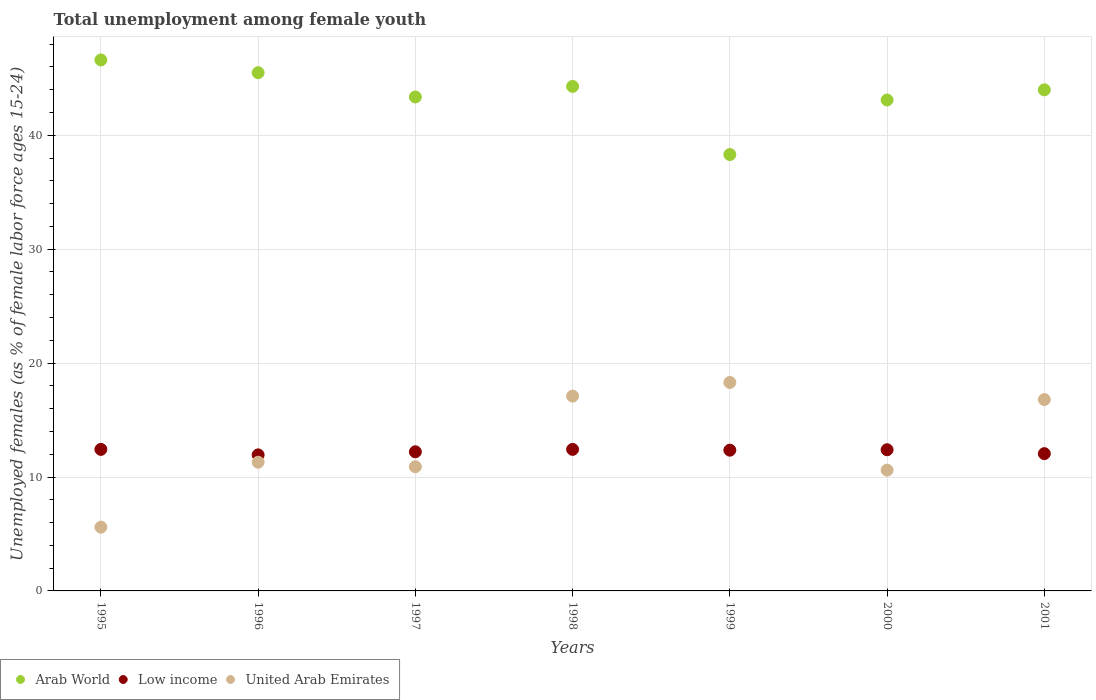What is the percentage of unemployed females in in United Arab Emirates in 1995?
Offer a terse response. 5.6. Across all years, what is the maximum percentage of unemployed females in in Low income?
Offer a very short reply. 12.43. Across all years, what is the minimum percentage of unemployed females in in United Arab Emirates?
Make the answer very short. 5.6. What is the total percentage of unemployed females in in United Arab Emirates in the graph?
Make the answer very short. 90.6. What is the difference between the percentage of unemployed females in in Arab World in 1997 and that in 2001?
Give a very brief answer. -0.63. What is the difference between the percentage of unemployed females in in Low income in 1998 and the percentage of unemployed females in in United Arab Emirates in 1995?
Your answer should be compact. 6.83. What is the average percentage of unemployed females in in Low income per year?
Offer a very short reply. 12.26. In the year 2001, what is the difference between the percentage of unemployed females in in Low income and percentage of unemployed females in in Arab World?
Your answer should be very brief. -31.94. What is the ratio of the percentage of unemployed females in in Arab World in 1997 to that in 2000?
Your answer should be compact. 1.01. What is the difference between the highest and the second highest percentage of unemployed females in in Arab World?
Provide a succinct answer. 1.12. What is the difference between the highest and the lowest percentage of unemployed females in in Low income?
Ensure brevity in your answer.  0.48. Is the sum of the percentage of unemployed females in in United Arab Emirates in 1998 and 2001 greater than the maximum percentage of unemployed females in in Low income across all years?
Provide a succinct answer. Yes. Does the percentage of unemployed females in in United Arab Emirates monotonically increase over the years?
Your answer should be compact. No. Is the percentage of unemployed females in in Low income strictly less than the percentage of unemployed females in in Arab World over the years?
Ensure brevity in your answer.  Yes. How many years are there in the graph?
Make the answer very short. 7. Where does the legend appear in the graph?
Your response must be concise. Bottom left. How are the legend labels stacked?
Ensure brevity in your answer.  Horizontal. What is the title of the graph?
Give a very brief answer. Total unemployment among female youth. What is the label or title of the X-axis?
Your answer should be compact. Years. What is the label or title of the Y-axis?
Your response must be concise. Unemployed females (as % of female labor force ages 15-24). What is the Unemployed females (as % of female labor force ages 15-24) of Arab World in 1995?
Your response must be concise. 46.61. What is the Unemployed females (as % of female labor force ages 15-24) in Low income in 1995?
Keep it short and to the point. 12.42. What is the Unemployed females (as % of female labor force ages 15-24) of United Arab Emirates in 1995?
Make the answer very short. 5.6. What is the Unemployed females (as % of female labor force ages 15-24) of Arab World in 1996?
Provide a succinct answer. 45.49. What is the Unemployed females (as % of female labor force ages 15-24) in Low income in 1996?
Give a very brief answer. 11.94. What is the Unemployed females (as % of female labor force ages 15-24) of United Arab Emirates in 1996?
Your answer should be very brief. 11.3. What is the Unemployed females (as % of female labor force ages 15-24) of Arab World in 1997?
Provide a succinct answer. 43.36. What is the Unemployed females (as % of female labor force ages 15-24) in Low income in 1997?
Provide a succinct answer. 12.21. What is the Unemployed females (as % of female labor force ages 15-24) of United Arab Emirates in 1997?
Make the answer very short. 10.9. What is the Unemployed females (as % of female labor force ages 15-24) in Arab World in 1998?
Make the answer very short. 44.29. What is the Unemployed females (as % of female labor force ages 15-24) in Low income in 1998?
Ensure brevity in your answer.  12.43. What is the Unemployed females (as % of female labor force ages 15-24) in United Arab Emirates in 1998?
Your answer should be compact. 17.1. What is the Unemployed females (as % of female labor force ages 15-24) of Arab World in 1999?
Your answer should be very brief. 38.31. What is the Unemployed females (as % of female labor force ages 15-24) in Low income in 1999?
Your answer should be very brief. 12.36. What is the Unemployed females (as % of female labor force ages 15-24) of United Arab Emirates in 1999?
Offer a very short reply. 18.3. What is the Unemployed females (as % of female labor force ages 15-24) of Arab World in 2000?
Make the answer very short. 43.1. What is the Unemployed females (as % of female labor force ages 15-24) in Low income in 2000?
Offer a terse response. 12.39. What is the Unemployed females (as % of female labor force ages 15-24) in United Arab Emirates in 2000?
Offer a terse response. 10.6. What is the Unemployed females (as % of female labor force ages 15-24) in Arab World in 2001?
Your answer should be compact. 43.99. What is the Unemployed females (as % of female labor force ages 15-24) of Low income in 2001?
Offer a very short reply. 12.05. What is the Unemployed females (as % of female labor force ages 15-24) of United Arab Emirates in 2001?
Offer a terse response. 16.8. Across all years, what is the maximum Unemployed females (as % of female labor force ages 15-24) in Arab World?
Ensure brevity in your answer.  46.61. Across all years, what is the maximum Unemployed females (as % of female labor force ages 15-24) of Low income?
Keep it short and to the point. 12.43. Across all years, what is the maximum Unemployed females (as % of female labor force ages 15-24) of United Arab Emirates?
Provide a short and direct response. 18.3. Across all years, what is the minimum Unemployed females (as % of female labor force ages 15-24) in Arab World?
Your answer should be very brief. 38.31. Across all years, what is the minimum Unemployed females (as % of female labor force ages 15-24) in Low income?
Your answer should be compact. 11.94. Across all years, what is the minimum Unemployed females (as % of female labor force ages 15-24) of United Arab Emirates?
Keep it short and to the point. 5.6. What is the total Unemployed females (as % of female labor force ages 15-24) in Arab World in the graph?
Give a very brief answer. 305.14. What is the total Unemployed females (as % of female labor force ages 15-24) in Low income in the graph?
Provide a succinct answer. 85.81. What is the total Unemployed females (as % of female labor force ages 15-24) in United Arab Emirates in the graph?
Your answer should be very brief. 90.6. What is the difference between the Unemployed females (as % of female labor force ages 15-24) in Arab World in 1995 and that in 1996?
Keep it short and to the point. 1.12. What is the difference between the Unemployed females (as % of female labor force ages 15-24) of Low income in 1995 and that in 1996?
Your answer should be very brief. 0.48. What is the difference between the Unemployed females (as % of female labor force ages 15-24) of United Arab Emirates in 1995 and that in 1996?
Keep it short and to the point. -5.7. What is the difference between the Unemployed females (as % of female labor force ages 15-24) in Arab World in 1995 and that in 1997?
Your answer should be compact. 3.25. What is the difference between the Unemployed females (as % of female labor force ages 15-24) of Low income in 1995 and that in 1997?
Provide a short and direct response. 0.21. What is the difference between the Unemployed females (as % of female labor force ages 15-24) of United Arab Emirates in 1995 and that in 1997?
Give a very brief answer. -5.3. What is the difference between the Unemployed females (as % of female labor force ages 15-24) in Arab World in 1995 and that in 1998?
Your answer should be very brief. 2.32. What is the difference between the Unemployed females (as % of female labor force ages 15-24) of Low income in 1995 and that in 1998?
Provide a short and direct response. -0. What is the difference between the Unemployed females (as % of female labor force ages 15-24) of Arab World in 1995 and that in 1999?
Offer a terse response. 8.3. What is the difference between the Unemployed females (as % of female labor force ages 15-24) in Low income in 1995 and that in 1999?
Offer a very short reply. 0.07. What is the difference between the Unemployed females (as % of female labor force ages 15-24) of Arab World in 1995 and that in 2000?
Offer a terse response. 3.52. What is the difference between the Unemployed females (as % of female labor force ages 15-24) of Low income in 1995 and that in 2000?
Your response must be concise. 0.03. What is the difference between the Unemployed females (as % of female labor force ages 15-24) in United Arab Emirates in 1995 and that in 2000?
Provide a short and direct response. -5. What is the difference between the Unemployed females (as % of female labor force ages 15-24) of Arab World in 1995 and that in 2001?
Give a very brief answer. 2.62. What is the difference between the Unemployed females (as % of female labor force ages 15-24) in Low income in 1995 and that in 2001?
Your response must be concise. 0.37. What is the difference between the Unemployed females (as % of female labor force ages 15-24) of United Arab Emirates in 1995 and that in 2001?
Provide a succinct answer. -11.2. What is the difference between the Unemployed females (as % of female labor force ages 15-24) of Arab World in 1996 and that in 1997?
Make the answer very short. 2.13. What is the difference between the Unemployed females (as % of female labor force ages 15-24) in Low income in 1996 and that in 1997?
Give a very brief answer. -0.27. What is the difference between the Unemployed females (as % of female labor force ages 15-24) in United Arab Emirates in 1996 and that in 1997?
Provide a short and direct response. 0.4. What is the difference between the Unemployed females (as % of female labor force ages 15-24) of Arab World in 1996 and that in 1998?
Your answer should be very brief. 1.21. What is the difference between the Unemployed females (as % of female labor force ages 15-24) of Low income in 1996 and that in 1998?
Your response must be concise. -0.48. What is the difference between the Unemployed females (as % of female labor force ages 15-24) of United Arab Emirates in 1996 and that in 1998?
Give a very brief answer. -5.8. What is the difference between the Unemployed females (as % of female labor force ages 15-24) in Arab World in 1996 and that in 1999?
Ensure brevity in your answer.  7.18. What is the difference between the Unemployed females (as % of female labor force ages 15-24) of Low income in 1996 and that in 1999?
Your response must be concise. -0.41. What is the difference between the Unemployed females (as % of female labor force ages 15-24) of Arab World in 1996 and that in 2000?
Make the answer very short. 2.4. What is the difference between the Unemployed females (as % of female labor force ages 15-24) of Low income in 1996 and that in 2000?
Provide a succinct answer. -0.45. What is the difference between the Unemployed females (as % of female labor force ages 15-24) of United Arab Emirates in 1996 and that in 2000?
Provide a short and direct response. 0.7. What is the difference between the Unemployed females (as % of female labor force ages 15-24) in Arab World in 1996 and that in 2001?
Offer a terse response. 1.51. What is the difference between the Unemployed females (as % of female labor force ages 15-24) in Low income in 1996 and that in 2001?
Provide a succinct answer. -0.11. What is the difference between the Unemployed females (as % of female labor force ages 15-24) of United Arab Emirates in 1996 and that in 2001?
Keep it short and to the point. -5.5. What is the difference between the Unemployed females (as % of female labor force ages 15-24) of Arab World in 1997 and that in 1998?
Keep it short and to the point. -0.93. What is the difference between the Unemployed females (as % of female labor force ages 15-24) of Low income in 1997 and that in 1998?
Ensure brevity in your answer.  -0.21. What is the difference between the Unemployed females (as % of female labor force ages 15-24) of Arab World in 1997 and that in 1999?
Offer a very short reply. 5.05. What is the difference between the Unemployed females (as % of female labor force ages 15-24) of Low income in 1997 and that in 1999?
Give a very brief answer. -0.14. What is the difference between the Unemployed females (as % of female labor force ages 15-24) of United Arab Emirates in 1997 and that in 1999?
Give a very brief answer. -7.4. What is the difference between the Unemployed females (as % of female labor force ages 15-24) of Arab World in 1997 and that in 2000?
Make the answer very short. 0.27. What is the difference between the Unemployed females (as % of female labor force ages 15-24) in Low income in 1997 and that in 2000?
Provide a succinct answer. -0.18. What is the difference between the Unemployed females (as % of female labor force ages 15-24) of Arab World in 1997 and that in 2001?
Offer a terse response. -0.63. What is the difference between the Unemployed females (as % of female labor force ages 15-24) of Low income in 1997 and that in 2001?
Your answer should be compact. 0.16. What is the difference between the Unemployed females (as % of female labor force ages 15-24) in United Arab Emirates in 1997 and that in 2001?
Your response must be concise. -5.9. What is the difference between the Unemployed females (as % of female labor force ages 15-24) of Arab World in 1998 and that in 1999?
Keep it short and to the point. 5.98. What is the difference between the Unemployed females (as % of female labor force ages 15-24) in Low income in 1998 and that in 1999?
Keep it short and to the point. 0.07. What is the difference between the Unemployed females (as % of female labor force ages 15-24) in Arab World in 1998 and that in 2000?
Your answer should be very brief. 1.19. What is the difference between the Unemployed females (as % of female labor force ages 15-24) in Low income in 1998 and that in 2000?
Make the answer very short. 0.03. What is the difference between the Unemployed females (as % of female labor force ages 15-24) in United Arab Emirates in 1998 and that in 2000?
Offer a very short reply. 6.5. What is the difference between the Unemployed females (as % of female labor force ages 15-24) in Arab World in 1998 and that in 2001?
Your answer should be compact. 0.3. What is the difference between the Unemployed females (as % of female labor force ages 15-24) in Low income in 1998 and that in 2001?
Offer a very short reply. 0.37. What is the difference between the Unemployed females (as % of female labor force ages 15-24) of United Arab Emirates in 1998 and that in 2001?
Provide a succinct answer. 0.3. What is the difference between the Unemployed females (as % of female labor force ages 15-24) in Arab World in 1999 and that in 2000?
Ensure brevity in your answer.  -4.79. What is the difference between the Unemployed females (as % of female labor force ages 15-24) in Low income in 1999 and that in 2000?
Ensure brevity in your answer.  -0.04. What is the difference between the Unemployed females (as % of female labor force ages 15-24) in Arab World in 1999 and that in 2001?
Offer a terse response. -5.68. What is the difference between the Unemployed females (as % of female labor force ages 15-24) of Low income in 1999 and that in 2001?
Make the answer very short. 0.31. What is the difference between the Unemployed females (as % of female labor force ages 15-24) of Arab World in 2000 and that in 2001?
Give a very brief answer. -0.89. What is the difference between the Unemployed females (as % of female labor force ages 15-24) of Low income in 2000 and that in 2001?
Provide a succinct answer. 0.34. What is the difference between the Unemployed females (as % of female labor force ages 15-24) of Arab World in 1995 and the Unemployed females (as % of female labor force ages 15-24) of Low income in 1996?
Ensure brevity in your answer.  34.67. What is the difference between the Unemployed females (as % of female labor force ages 15-24) of Arab World in 1995 and the Unemployed females (as % of female labor force ages 15-24) of United Arab Emirates in 1996?
Offer a terse response. 35.31. What is the difference between the Unemployed females (as % of female labor force ages 15-24) in Arab World in 1995 and the Unemployed females (as % of female labor force ages 15-24) in Low income in 1997?
Provide a succinct answer. 34.4. What is the difference between the Unemployed females (as % of female labor force ages 15-24) of Arab World in 1995 and the Unemployed females (as % of female labor force ages 15-24) of United Arab Emirates in 1997?
Provide a short and direct response. 35.71. What is the difference between the Unemployed females (as % of female labor force ages 15-24) in Low income in 1995 and the Unemployed females (as % of female labor force ages 15-24) in United Arab Emirates in 1997?
Your answer should be very brief. 1.52. What is the difference between the Unemployed females (as % of female labor force ages 15-24) of Arab World in 1995 and the Unemployed females (as % of female labor force ages 15-24) of Low income in 1998?
Provide a succinct answer. 34.19. What is the difference between the Unemployed females (as % of female labor force ages 15-24) in Arab World in 1995 and the Unemployed females (as % of female labor force ages 15-24) in United Arab Emirates in 1998?
Your answer should be very brief. 29.51. What is the difference between the Unemployed females (as % of female labor force ages 15-24) of Low income in 1995 and the Unemployed females (as % of female labor force ages 15-24) of United Arab Emirates in 1998?
Keep it short and to the point. -4.67. What is the difference between the Unemployed females (as % of female labor force ages 15-24) in Arab World in 1995 and the Unemployed females (as % of female labor force ages 15-24) in Low income in 1999?
Keep it short and to the point. 34.26. What is the difference between the Unemployed females (as % of female labor force ages 15-24) of Arab World in 1995 and the Unemployed females (as % of female labor force ages 15-24) of United Arab Emirates in 1999?
Make the answer very short. 28.31. What is the difference between the Unemployed females (as % of female labor force ages 15-24) in Low income in 1995 and the Unemployed females (as % of female labor force ages 15-24) in United Arab Emirates in 1999?
Your answer should be very brief. -5.88. What is the difference between the Unemployed females (as % of female labor force ages 15-24) of Arab World in 1995 and the Unemployed females (as % of female labor force ages 15-24) of Low income in 2000?
Your answer should be compact. 34.22. What is the difference between the Unemployed females (as % of female labor force ages 15-24) in Arab World in 1995 and the Unemployed females (as % of female labor force ages 15-24) in United Arab Emirates in 2000?
Provide a succinct answer. 36.01. What is the difference between the Unemployed females (as % of female labor force ages 15-24) in Low income in 1995 and the Unemployed females (as % of female labor force ages 15-24) in United Arab Emirates in 2000?
Your response must be concise. 1.82. What is the difference between the Unemployed females (as % of female labor force ages 15-24) in Arab World in 1995 and the Unemployed females (as % of female labor force ages 15-24) in Low income in 2001?
Your answer should be compact. 34.56. What is the difference between the Unemployed females (as % of female labor force ages 15-24) of Arab World in 1995 and the Unemployed females (as % of female labor force ages 15-24) of United Arab Emirates in 2001?
Offer a very short reply. 29.81. What is the difference between the Unemployed females (as % of female labor force ages 15-24) in Low income in 1995 and the Unemployed females (as % of female labor force ages 15-24) in United Arab Emirates in 2001?
Your answer should be very brief. -4.38. What is the difference between the Unemployed females (as % of female labor force ages 15-24) of Arab World in 1996 and the Unemployed females (as % of female labor force ages 15-24) of Low income in 1997?
Keep it short and to the point. 33.28. What is the difference between the Unemployed females (as % of female labor force ages 15-24) of Arab World in 1996 and the Unemployed females (as % of female labor force ages 15-24) of United Arab Emirates in 1997?
Your answer should be very brief. 34.59. What is the difference between the Unemployed females (as % of female labor force ages 15-24) in Low income in 1996 and the Unemployed females (as % of female labor force ages 15-24) in United Arab Emirates in 1997?
Offer a terse response. 1.04. What is the difference between the Unemployed females (as % of female labor force ages 15-24) of Arab World in 1996 and the Unemployed females (as % of female labor force ages 15-24) of Low income in 1998?
Your answer should be compact. 33.07. What is the difference between the Unemployed females (as % of female labor force ages 15-24) in Arab World in 1996 and the Unemployed females (as % of female labor force ages 15-24) in United Arab Emirates in 1998?
Your response must be concise. 28.39. What is the difference between the Unemployed females (as % of female labor force ages 15-24) of Low income in 1996 and the Unemployed females (as % of female labor force ages 15-24) of United Arab Emirates in 1998?
Make the answer very short. -5.16. What is the difference between the Unemployed females (as % of female labor force ages 15-24) in Arab World in 1996 and the Unemployed females (as % of female labor force ages 15-24) in Low income in 1999?
Your response must be concise. 33.14. What is the difference between the Unemployed females (as % of female labor force ages 15-24) in Arab World in 1996 and the Unemployed females (as % of female labor force ages 15-24) in United Arab Emirates in 1999?
Your answer should be very brief. 27.19. What is the difference between the Unemployed females (as % of female labor force ages 15-24) of Low income in 1996 and the Unemployed females (as % of female labor force ages 15-24) of United Arab Emirates in 1999?
Offer a very short reply. -6.36. What is the difference between the Unemployed females (as % of female labor force ages 15-24) of Arab World in 1996 and the Unemployed females (as % of female labor force ages 15-24) of Low income in 2000?
Provide a short and direct response. 33.1. What is the difference between the Unemployed females (as % of female labor force ages 15-24) of Arab World in 1996 and the Unemployed females (as % of female labor force ages 15-24) of United Arab Emirates in 2000?
Your response must be concise. 34.89. What is the difference between the Unemployed females (as % of female labor force ages 15-24) of Low income in 1996 and the Unemployed females (as % of female labor force ages 15-24) of United Arab Emirates in 2000?
Offer a very short reply. 1.34. What is the difference between the Unemployed females (as % of female labor force ages 15-24) in Arab World in 1996 and the Unemployed females (as % of female labor force ages 15-24) in Low income in 2001?
Provide a short and direct response. 33.44. What is the difference between the Unemployed females (as % of female labor force ages 15-24) of Arab World in 1996 and the Unemployed females (as % of female labor force ages 15-24) of United Arab Emirates in 2001?
Your answer should be compact. 28.69. What is the difference between the Unemployed females (as % of female labor force ages 15-24) in Low income in 1996 and the Unemployed females (as % of female labor force ages 15-24) in United Arab Emirates in 2001?
Offer a very short reply. -4.86. What is the difference between the Unemployed females (as % of female labor force ages 15-24) in Arab World in 1997 and the Unemployed females (as % of female labor force ages 15-24) in Low income in 1998?
Keep it short and to the point. 30.94. What is the difference between the Unemployed females (as % of female labor force ages 15-24) in Arab World in 1997 and the Unemployed females (as % of female labor force ages 15-24) in United Arab Emirates in 1998?
Make the answer very short. 26.26. What is the difference between the Unemployed females (as % of female labor force ages 15-24) of Low income in 1997 and the Unemployed females (as % of female labor force ages 15-24) of United Arab Emirates in 1998?
Give a very brief answer. -4.89. What is the difference between the Unemployed females (as % of female labor force ages 15-24) of Arab World in 1997 and the Unemployed females (as % of female labor force ages 15-24) of Low income in 1999?
Ensure brevity in your answer.  31.01. What is the difference between the Unemployed females (as % of female labor force ages 15-24) in Arab World in 1997 and the Unemployed females (as % of female labor force ages 15-24) in United Arab Emirates in 1999?
Your answer should be very brief. 25.06. What is the difference between the Unemployed females (as % of female labor force ages 15-24) of Low income in 1997 and the Unemployed females (as % of female labor force ages 15-24) of United Arab Emirates in 1999?
Give a very brief answer. -6.09. What is the difference between the Unemployed females (as % of female labor force ages 15-24) of Arab World in 1997 and the Unemployed females (as % of female labor force ages 15-24) of Low income in 2000?
Keep it short and to the point. 30.97. What is the difference between the Unemployed females (as % of female labor force ages 15-24) in Arab World in 1997 and the Unemployed females (as % of female labor force ages 15-24) in United Arab Emirates in 2000?
Your answer should be very brief. 32.76. What is the difference between the Unemployed females (as % of female labor force ages 15-24) of Low income in 1997 and the Unemployed females (as % of female labor force ages 15-24) of United Arab Emirates in 2000?
Your answer should be very brief. 1.61. What is the difference between the Unemployed females (as % of female labor force ages 15-24) in Arab World in 1997 and the Unemployed females (as % of female labor force ages 15-24) in Low income in 2001?
Ensure brevity in your answer.  31.31. What is the difference between the Unemployed females (as % of female labor force ages 15-24) of Arab World in 1997 and the Unemployed females (as % of female labor force ages 15-24) of United Arab Emirates in 2001?
Offer a terse response. 26.56. What is the difference between the Unemployed females (as % of female labor force ages 15-24) of Low income in 1997 and the Unemployed females (as % of female labor force ages 15-24) of United Arab Emirates in 2001?
Your response must be concise. -4.59. What is the difference between the Unemployed females (as % of female labor force ages 15-24) in Arab World in 1998 and the Unemployed females (as % of female labor force ages 15-24) in Low income in 1999?
Ensure brevity in your answer.  31.93. What is the difference between the Unemployed females (as % of female labor force ages 15-24) of Arab World in 1998 and the Unemployed females (as % of female labor force ages 15-24) of United Arab Emirates in 1999?
Ensure brevity in your answer.  25.99. What is the difference between the Unemployed females (as % of female labor force ages 15-24) in Low income in 1998 and the Unemployed females (as % of female labor force ages 15-24) in United Arab Emirates in 1999?
Make the answer very short. -5.87. What is the difference between the Unemployed females (as % of female labor force ages 15-24) in Arab World in 1998 and the Unemployed females (as % of female labor force ages 15-24) in Low income in 2000?
Your answer should be very brief. 31.89. What is the difference between the Unemployed females (as % of female labor force ages 15-24) in Arab World in 1998 and the Unemployed females (as % of female labor force ages 15-24) in United Arab Emirates in 2000?
Provide a short and direct response. 33.69. What is the difference between the Unemployed females (as % of female labor force ages 15-24) in Low income in 1998 and the Unemployed females (as % of female labor force ages 15-24) in United Arab Emirates in 2000?
Offer a very short reply. 1.83. What is the difference between the Unemployed females (as % of female labor force ages 15-24) of Arab World in 1998 and the Unemployed females (as % of female labor force ages 15-24) of Low income in 2001?
Keep it short and to the point. 32.24. What is the difference between the Unemployed females (as % of female labor force ages 15-24) of Arab World in 1998 and the Unemployed females (as % of female labor force ages 15-24) of United Arab Emirates in 2001?
Give a very brief answer. 27.49. What is the difference between the Unemployed females (as % of female labor force ages 15-24) in Low income in 1998 and the Unemployed females (as % of female labor force ages 15-24) in United Arab Emirates in 2001?
Keep it short and to the point. -4.37. What is the difference between the Unemployed females (as % of female labor force ages 15-24) in Arab World in 1999 and the Unemployed females (as % of female labor force ages 15-24) in Low income in 2000?
Your response must be concise. 25.91. What is the difference between the Unemployed females (as % of female labor force ages 15-24) of Arab World in 1999 and the Unemployed females (as % of female labor force ages 15-24) of United Arab Emirates in 2000?
Keep it short and to the point. 27.71. What is the difference between the Unemployed females (as % of female labor force ages 15-24) of Low income in 1999 and the Unemployed females (as % of female labor force ages 15-24) of United Arab Emirates in 2000?
Your answer should be very brief. 1.76. What is the difference between the Unemployed females (as % of female labor force ages 15-24) in Arab World in 1999 and the Unemployed females (as % of female labor force ages 15-24) in Low income in 2001?
Offer a terse response. 26.26. What is the difference between the Unemployed females (as % of female labor force ages 15-24) of Arab World in 1999 and the Unemployed females (as % of female labor force ages 15-24) of United Arab Emirates in 2001?
Provide a short and direct response. 21.51. What is the difference between the Unemployed females (as % of female labor force ages 15-24) in Low income in 1999 and the Unemployed females (as % of female labor force ages 15-24) in United Arab Emirates in 2001?
Provide a succinct answer. -4.44. What is the difference between the Unemployed females (as % of female labor force ages 15-24) of Arab World in 2000 and the Unemployed females (as % of female labor force ages 15-24) of Low income in 2001?
Your response must be concise. 31.04. What is the difference between the Unemployed females (as % of female labor force ages 15-24) of Arab World in 2000 and the Unemployed females (as % of female labor force ages 15-24) of United Arab Emirates in 2001?
Give a very brief answer. 26.3. What is the difference between the Unemployed females (as % of female labor force ages 15-24) in Low income in 2000 and the Unemployed females (as % of female labor force ages 15-24) in United Arab Emirates in 2001?
Offer a terse response. -4.41. What is the average Unemployed females (as % of female labor force ages 15-24) in Arab World per year?
Ensure brevity in your answer.  43.59. What is the average Unemployed females (as % of female labor force ages 15-24) in Low income per year?
Provide a succinct answer. 12.26. What is the average Unemployed females (as % of female labor force ages 15-24) of United Arab Emirates per year?
Your answer should be compact. 12.94. In the year 1995, what is the difference between the Unemployed females (as % of female labor force ages 15-24) of Arab World and Unemployed females (as % of female labor force ages 15-24) of Low income?
Make the answer very short. 34.19. In the year 1995, what is the difference between the Unemployed females (as % of female labor force ages 15-24) of Arab World and Unemployed females (as % of female labor force ages 15-24) of United Arab Emirates?
Provide a succinct answer. 41.01. In the year 1995, what is the difference between the Unemployed females (as % of female labor force ages 15-24) in Low income and Unemployed females (as % of female labor force ages 15-24) in United Arab Emirates?
Give a very brief answer. 6.83. In the year 1996, what is the difference between the Unemployed females (as % of female labor force ages 15-24) in Arab World and Unemployed females (as % of female labor force ages 15-24) in Low income?
Your response must be concise. 33.55. In the year 1996, what is the difference between the Unemployed females (as % of female labor force ages 15-24) in Arab World and Unemployed females (as % of female labor force ages 15-24) in United Arab Emirates?
Give a very brief answer. 34.19. In the year 1996, what is the difference between the Unemployed females (as % of female labor force ages 15-24) of Low income and Unemployed females (as % of female labor force ages 15-24) of United Arab Emirates?
Keep it short and to the point. 0.64. In the year 1997, what is the difference between the Unemployed females (as % of female labor force ages 15-24) of Arab World and Unemployed females (as % of female labor force ages 15-24) of Low income?
Give a very brief answer. 31.15. In the year 1997, what is the difference between the Unemployed females (as % of female labor force ages 15-24) in Arab World and Unemployed females (as % of female labor force ages 15-24) in United Arab Emirates?
Offer a terse response. 32.46. In the year 1997, what is the difference between the Unemployed females (as % of female labor force ages 15-24) in Low income and Unemployed females (as % of female labor force ages 15-24) in United Arab Emirates?
Your answer should be compact. 1.31. In the year 1998, what is the difference between the Unemployed females (as % of female labor force ages 15-24) of Arab World and Unemployed females (as % of female labor force ages 15-24) of Low income?
Keep it short and to the point. 31.86. In the year 1998, what is the difference between the Unemployed females (as % of female labor force ages 15-24) of Arab World and Unemployed females (as % of female labor force ages 15-24) of United Arab Emirates?
Your answer should be very brief. 27.19. In the year 1998, what is the difference between the Unemployed females (as % of female labor force ages 15-24) in Low income and Unemployed females (as % of female labor force ages 15-24) in United Arab Emirates?
Offer a terse response. -4.67. In the year 1999, what is the difference between the Unemployed females (as % of female labor force ages 15-24) of Arab World and Unemployed females (as % of female labor force ages 15-24) of Low income?
Offer a terse response. 25.95. In the year 1999, what is the difference between the Unemployed females (as % of female labor force ages 15-24) of Arab World and Unemployed females (as % of female labor force ages 15-24) of United Arab Emirates?
Provide a succinct answer. 20.01. In the year 1999, what is the difference between the Unemployed females (as % of female labor force ages 15-24) in Low income and Unemployed females (as % of female labor force ages 15-24) in United Arab Emirates?
Offer a terse response. -5.94. In the year 2000, what is the difference between the Unemployed females (as % of female labor force ages 15-24) in Arab World and Unemployed females (as % of female labor force ages 15-24) in Low income?
Provide a succinct answer. 30.7. In the year 2000, what is the difference between the Unemployed females (as % of female labor force ages 15-24) of Arab World and Unemployed females (as % of female labor force ages 15-24) of United Arab Emirates?
Your response must be concise. 32.5. In the year 2000, what is the difference between the Unemployed females (as % of female labor force ages 15-24) in Low income and Unemployed females (as % of female labor force ages 15-24) in United Arab Emirates?
Your answer should be compact. 1.79. In the year 2001, what is the difference between the Unemployed females (as % of female labor force ages 15-24) of Arab World and Unemployed females (as % of female labor force ages 15-24) of Low income?
Provide a short and direct response. 31.94. In the year 2001, what is the difference between the Unemployed females (as % of female labor force ages 15-24) in Arab World and Unemployed females (as % of female labor force ages 15-24) in United Arab Emirates?
Give a very brief answer. 27.19. In the year 2001, what is the difference between the Unemployed females (as % of female labor force ages 15-24) of Low income and Unemployed females (as % of female labor force ages 15-24) of United Arab Emirates?
Give a very brief answer. -4.75. What is the ratio of the Unemployed females (as % of female labor force ages 15-24) in Arab World in 1995 to that in 1996?
Keep it short and to the point. 1.02. What is the ratio of the Unemployed females (as % of female labor force ages 15-24) in Low income in 1995 to that in 1996?
Ensure brevity in your answer.  1.04. What is the ratio of the Unemployed females (as % of female labor force ages 15-24) in United Arab Emirates in 1995 to that in 1996?
Offer a terse response. 0.5. What is the ratio of the Unemployed females (as % of female labor force ages 15-24) in Arab World in 1995 to that in 1997?
Ensure brevity in your answer.  1.07. What is the ratio of the Unemployed females (as % of female labor force ages 15-24) of Low income in 1995 to that in 1997?
Your answer should be compact. 1.02. What is the ratio of the Unemployed females (as % of female labor force ages 15-24) of United Arab Emirates in 1995 to that in 1997?
Your answer should be compact. 0.51. What is the ratio of the Unemployed females (as % of female labor force ages 15-24) in Arab World in 1995 to that in 1998?
Your answer should be compact. 1.05. What is the ratio of the Unemployed females (as % of female labor force ages 15-24) of United Arab Emirates in 1995 to that in 1998?
Your response must be concise. 0.33. What is the ratio of the Unemployed females (as % of female labor force ages 15-24) in Arab World in 1995 to that in 1999?
Your answer should be very brief. 1.22. What is the ratio of the Unemployed females (as % of female labor force ages 15-24) in Low income in 1995 to that in 1999?
Your answer should be very brief. 1.01. What is the ratio of the Unemployed females (as % of female labor force ages 15-24) of United Arab Emirates in 1995 to that in 1999?
Ensure brevity in your answer.  0.31. What is the ratio of the Unemployed females (as % of female labor force ages 15-24) in Arab World in 1995 to that in 2000?
Provide a short and direct response. 1.08. What is the ratio of the Unemployed females (as % of female labor force ages 15-24) of United Arab Emirates in 1995 to that in 2000?
Your answer should be compact. 0.53. What is the ratio of the Unemployed females (as % of female labor force ages 15-24) in Arab World in 1995 to that in 2001?
Provide a succinct answer. 1.06. What is the ratio of the Unemployed females (as % of female labor force ages 15-24) of Low income in 1995 to that in 2001?
Ensure brevity in your answer.  1.03. What is the ratio of the Unemployed females (as % of female labor force ages 15-24) in Arab World in 1996 to that in 1997?
Offer a terse response. 1.05. What is the ratio of the Unemployed females (as % of female labor force ages 15-24) of Low income in 1996 to that in 1997?
Provide a short and direct response. 0.98. What is the ratio of the Unemployed females (as % of female labor force ages 15-24) of United Arab Emirates in 1996 to that in 1997?
Ensure brevity in your answer.  1.04. What is the ratio of the Unemployed females (as % of female labor force ages 15-24) in Arab World in 1996 to that in 1998?
Ensure brevity in your answer.  1.03. What is the ratio of the Unemployed females (as % of female labor force ages 15-24) of Low income in 1996 to that in 1998?
Your answer should be very brief. 0.96. What is the ratio of the Unemployed females (as % of female labor force ages 15-24) in United Arab Emirates in 1996 to that in 1998?
Offer a terse response. 0.66. What is the ratio of the Unemployed females (as % of female labor force ages 15-24) of Arab World in 1996 to that in 1999?
Provide a short and direct response. 1.19. What is the ratio of the Unemployed females (as % of female labor force ages 15-24) in Low income in 1996 to that in 1999?
Provide a short and direct response. 0.97. What is the ratio of the Unemployed females (as % of female labor force ages 15-24) of United Arab Emirates in 1996 to that in 1999?
Offer a terse response. 0.62. What is the ratio of the Unemployed females (as % of female labor force ages 15-24) in Arab World in 1996 to that in 2000?
Ensure brevity in your answer.  1.06. What is the ratio of the Unemployed females (as % of female labor force ages 15-24) in Low income in 1996 to that in 2000?
Make the answer very short. 0.96. What is the ratio of the Unemployed females (as % of female labor force ages 15-24) in United Arab Emirates in 1996 to that in 2000?
Offer a terse response. 1.07. What is the ratio of the Unemployed females (as % of female labor force ages 15-24) of Arab World in 1996 to that in 2001?
Offer a very short reply. 1.03. What is the ratio of the Unemployed females (as % of female labor force ages 15-24) of United Arab Emirates in 1996 to that in 2001?
Keep it short and to the point. 0.67. What is the ratio of the Unemployed females (as % of female labor force ages 15-24) in Arab World in 1997 to that in 1998?
Give a very brief answer. 0.98. What is the ratio of the Unemployed females (as % of female labor force ages 15-24) of Low income in 1997 to that in 1998?
Ensure brevity in your answer.  0.98. What is the ratio of the Unemployed females (as % of female labor force ages 15-24) of United Arab Emirates in 1997 to that in 1998?
Offer a terse response. 0.64. What is the ratio of the Unemployed females (as % of female labor force ages 15-24) of Arab World in 1997 to that in 1999?
Make the answer very short. 1.13. What is the ratio of the Unemployed females (as % of female labor force ages 15-24) in Low income in 1997 to that in 1999?
Your answer should be very brief. 0.99. What is the ratio of the Unemployed females (as % of female labor force ages 15-24) of United Arab Emirates in 1997 to that in 1999?
Offer a terse response. 0.6. What is the ratio of the Unemployed females (as % of female labor force ages 15-24) of Arab World in 1997 to that in 2000?
Make the answer very short. 1.01. What is the ratio of the Unemployed females (as % of female labor force ages 15-24) in Low income in 1997 to that in 2000?
Provide a short and direct response. 0.99. What is the ratio of the Unemployed females (as % of female labor force ages 15-24) in United Arab Emirates in 1997 to that in 2000?
Your answer should be compact. 1.03. What is the ratio of the Unemployed females (as % of female labor force ages 15-24) of Arab World in 1997 to that in 2001?
Your response must be concise. 0.99. What is the ratio of the Unemployed females (as % of female labor force ages 15-24) in Low income in 1997 to that in 2001?
Your answer should be compact. 1.01. What is the ratio of the Unemployed females (as % of female labor force ages 15-24) of United Arab Emirates in 1997 to that in 2001?
Make the answer very short. 0.65. What is the ratio of the Unemployed females (as % of female labor force ages 15-24) of Arab World in 1998 to that in 1999?
Your answer should be very brief. 1.16. What is the ratio of the Unemployed females (as % of female labor force ages 15-24) of Low income in 1998 to that in 1999?
Make the answer very short. 1.01. What is the ratio of the Unemployed females (as % of female labor force ages 15-24) of United Arab Emirates in 1998 to that in 1999?
Provide a succinct answer. 0.93. What is the ratio of the Unemployed females (as % of female labor force ages 15-24) of Arab World in 1998 to that in 2000?
Provide a succinct answer. 1.03. What is the ratio of the Unemployed females (as % of female labor force ages 15-24) of Low income in 1998 to that in 2000?
Make the answer very short. 1. What is the ratio of the Unemployed females (as % of female labor force ages 15-24) in United Arab Emirates in 1998 to that in 2000?
Ensure brevity in your answer.  1.61. What is the ratio of the Unemployed females (as % of female labor force ages 15-24) in Arab World in 1998 to that in 2001?
Give a very brief answer. 1.01. What is the ratio of the Unemployed females (as % of female labor force ages 15-24) in Low income in 1998 to that in 2001?
Give a very brief answer. 1.03. What is the ratio of the Unemployed females (as % of female labor force ages 15-24) in United Arab Emirates in 1998 to that in 2001?
Your response must be concise. 1.02. What is the ratio of the Unemployed females (as % of female labor force ages 15-24) in United Arab Emirates in 1999 to that in 2000?
Ensure brevity in your answer.  1.73. What is the ratio of the Unemployed females (as % of female labor force ages 15-24) in Arab World in 1999 to that in 2001?
Give a very brief answer. 0.87. What is the ratio of the Unemployed females (as % of female labor force ages 15-24) in Low income in 1999 to that in 2001?
Provide a succinct answer. 1.03. What is the ratio of the Unemployed females (as % of female labor force ages 15-24) of United Arab Emirates in 1999 to that in 2001?
Offer a terse response. 1.09. What is the ratio of the Unemployed females (as % of female labor force ages 15-24) of Arab World in 2000 to that in 2001?
Offer a very short reply. 0.98. What is the ratio of the Unemployed females (as % of female labor force ages 15-24) of Low income in 2000 to that in 2001?
Your answer should be compact. 1.03. What is the ratio of the Unemployed females (as % of female labor force ages 15-24) in United Arab Emirates in 2000 to that in 2001?
Offer a terse response. 0.63. What is the difference between the highest and the second highest Unemployed females (as % of female labor force ages 15-24) in Arab World?
Ensure brevity in your answer.  1.12. What is the difference between the highest and the second highest Unemployed females (as % of female labor force ages 15-24) in Low income?
Offer a terse response. 0. What is the difference between the highest and the lowest Unemployed females (as % of female labor force ages 15-24) in Arab World?
Offer a very short reply. 8.3. What is the difference between the highest and the lowest Unemployed females (as % of female labor force ages 15-24) of Low income?
Provide a succinct answer. 0.48. 